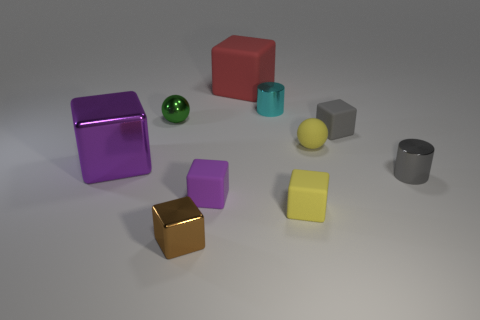Subtract all yellow blocks. How many blocks are left? 5 Subtract all metallic blocks. How many blocks are left? 4 Subtract 1 cubes. How many cubes are left? 5 Subtract all red cylinders. Subtract all red balls. How many cylinders are left? 2 Subtract all spheres. How many objects are left? 8 Subtract all big red metallic cubes. Subtract all yellow rubber spheres. How many objects are left? 9 Add 6 green shiny balls. How many green shiny balls are left? 7 Add 1 small yellow things. How many small yellow things exist? 3 Subtract 0 red cylinders. How many objects are left? 10 